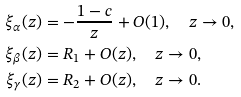<formula> <loc_0><loc_0><loc_500><loc_500>\xi _ { \alpha } ( z ) & = - \frac { 1 - c } { z } + O ( 1 ) , \quad z \rightarrow 0 , \\ \xi _ { \beta } ( z ) & = R _ { 1 } + O ( z ) , \quad z \rightarrow 0 , \\ \xi _ { \gamma } ( z ) & = R _ { 2 } + O ( z ) , \quad z \rightarrow 0 .</formula> 